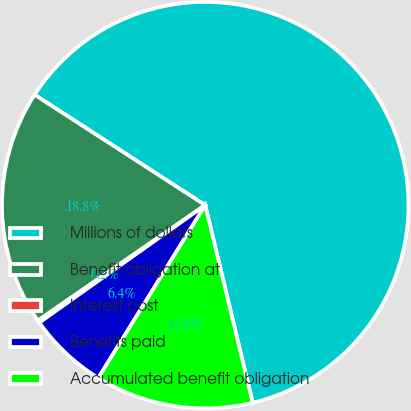<chart> <loc_0><loc_0><loc_500><loc_500><pie_chart><fcel>Millions of dollars<fcel>Benefit obligation at<fcel>Interest cost<fcel>Benefits paid<fcel>Accumulated benefit obligation<nl><fcel>62.11%<fcel>18.76%<fcel>0.19%<fcel>6.38%<fcel>12.57%<nl></chart> 